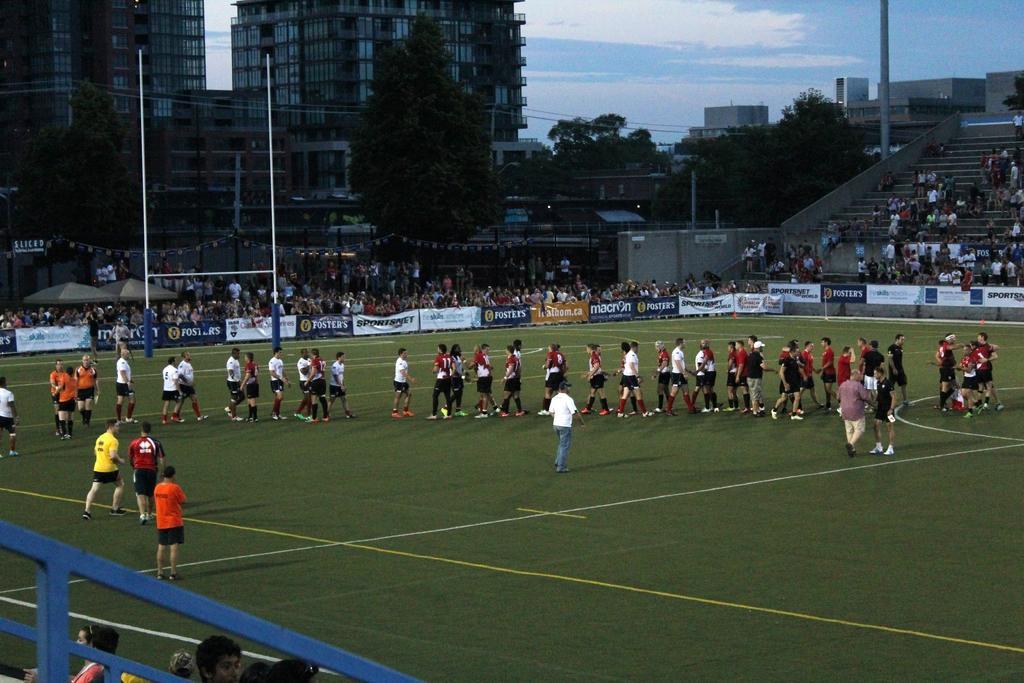Describe this image in one or two sentences. In this image I can see number of people in the ground. In the background I can see number of trees, buildings and clear view of sky. 